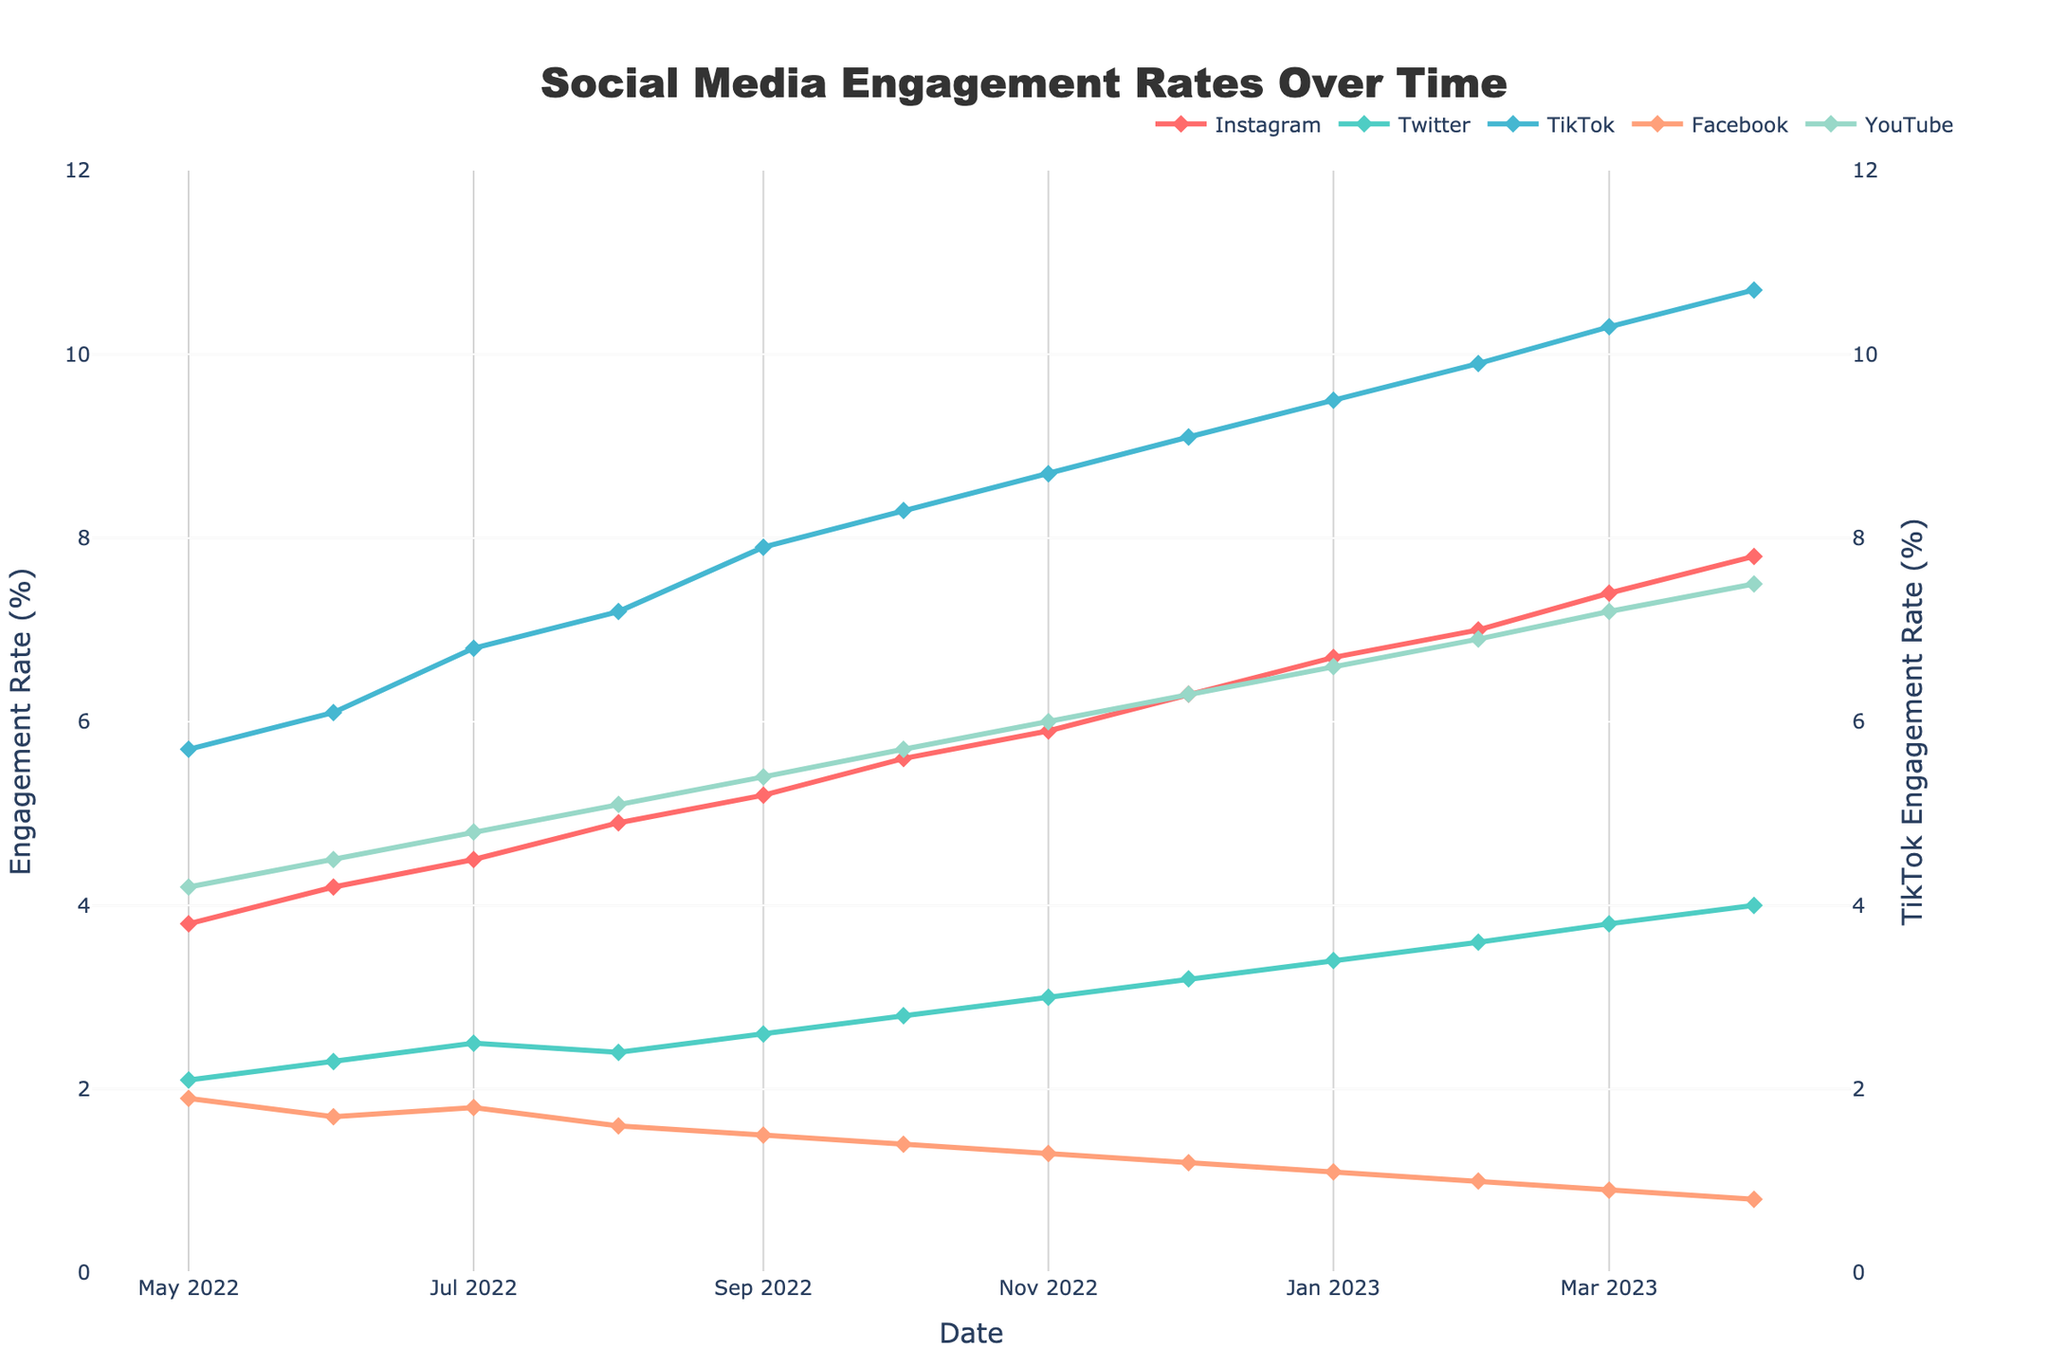Which platform had the highest engagement rate in April 2023? Looking at the data points for April 2023, we observe that TikTok has the highest engagement rate.
Answer: TikTok How did Instagram's engagement rate change between January 2023 and April 2023? The engagement rate of Instagram in January 2023 is 6.7%, and it increases to 7.8% in April 2023. The difference is 7.8% - 6.7% = 1.1%.
Answer: It increased by 1.1% Which platform had the steepest increase in engagement rate from May 2022 to April 2023? By calculating the difference in engagement rates from May 2022 to April 2023 for all platforms:
Instagram: 7.8 - 3.8 = 4.0
Twitter: 4.0 - 2.1 = 1.9
TikTok: 10.7 - 5.7 = 5.0
Facebook: 0.8 - 1.9 = -1.1
YouTube: 7.5 - 4.2 = 3.3
TikTok had the steepest increase of 5.0%.
Answer: TikTok Which platform had the lowest engagement rate in February 2023? Observing the engagement rates for February 2023, Facebook has the lowest rate of 1.0%.
Answer: Facebook Compare the engagement rate trends of YouTube and Twitter over the past year. YouTube shows a consistent increase over the year, starting from 4.2% in May 2022 and reaching 7.5% in April 2023. Twitter also shows a consistent increase from 2.1% in May 2022 to 4.0% in April 2023. Both platforms show growth but YouTube starts higher and ends higher.
Answer: Both increased, but YouTube starts and ends higher What is the average engagement rate of TikTok over the past year? Averaging the monthly engagement rates of TikTok:
(5.7 + 6.1 + 6.8 + 7.2 + 7.9 + 8.3 + 8.7 + 9.1 + 9.5 + 9.9 + 10.3 + 10.7) / 12 ≈ 8.2%
Answer: 8.2% How does the trend in engagement rate for Facebook compare to Instagram over the past year? Facebook shows a decreasing trend from 1.9% in May 2022 to 0.8% in April 2023. Instagram, however, shows an increasing trend from 3.8% in May 2022 to 7.8% in April 2023. Thus, while Facebook's engagement decreases, Instagram's engagement consistently increases.
Answer: Facebook decreases, Instagram increases 